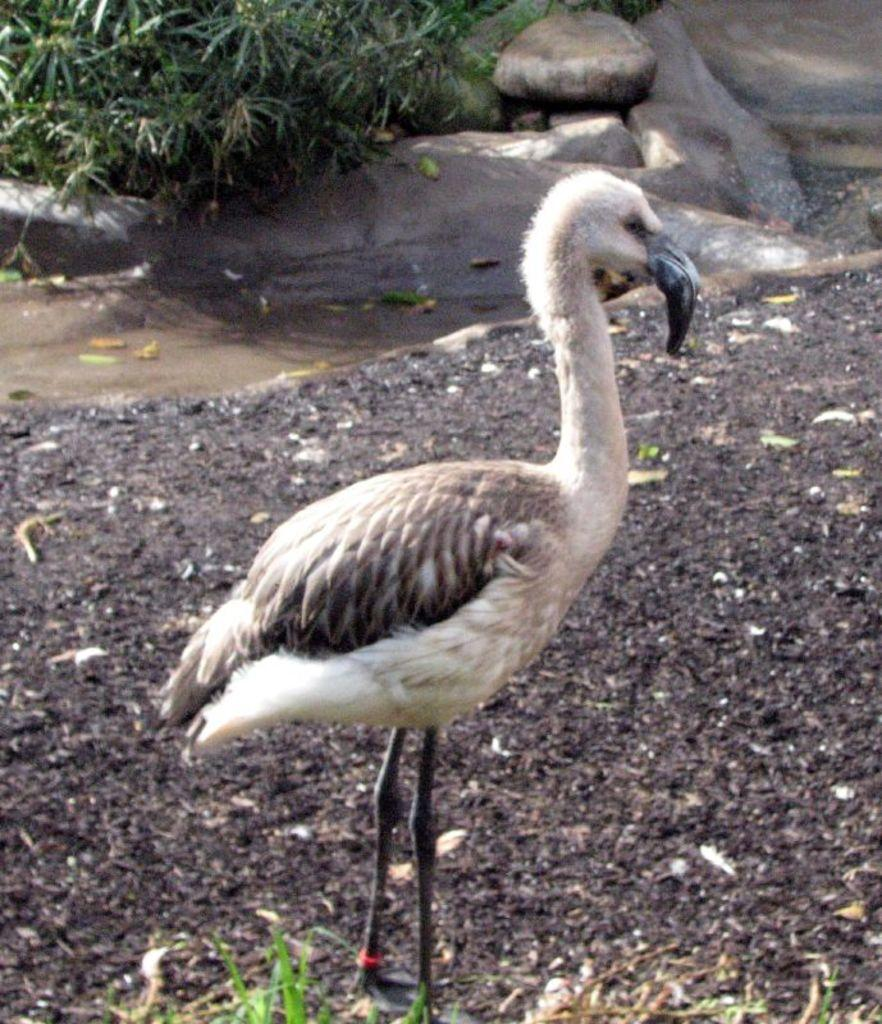What type of animal can be seen on the ground in the image? There is a bird on the ground in the image. What other objects or features can be seen in the image? There are rocks and plants in the image. What type of silk is being used to create a powdery substance in the image? There is no silk or powdery substance present in the image; it features a bird on the ground, rocks, and plants. 